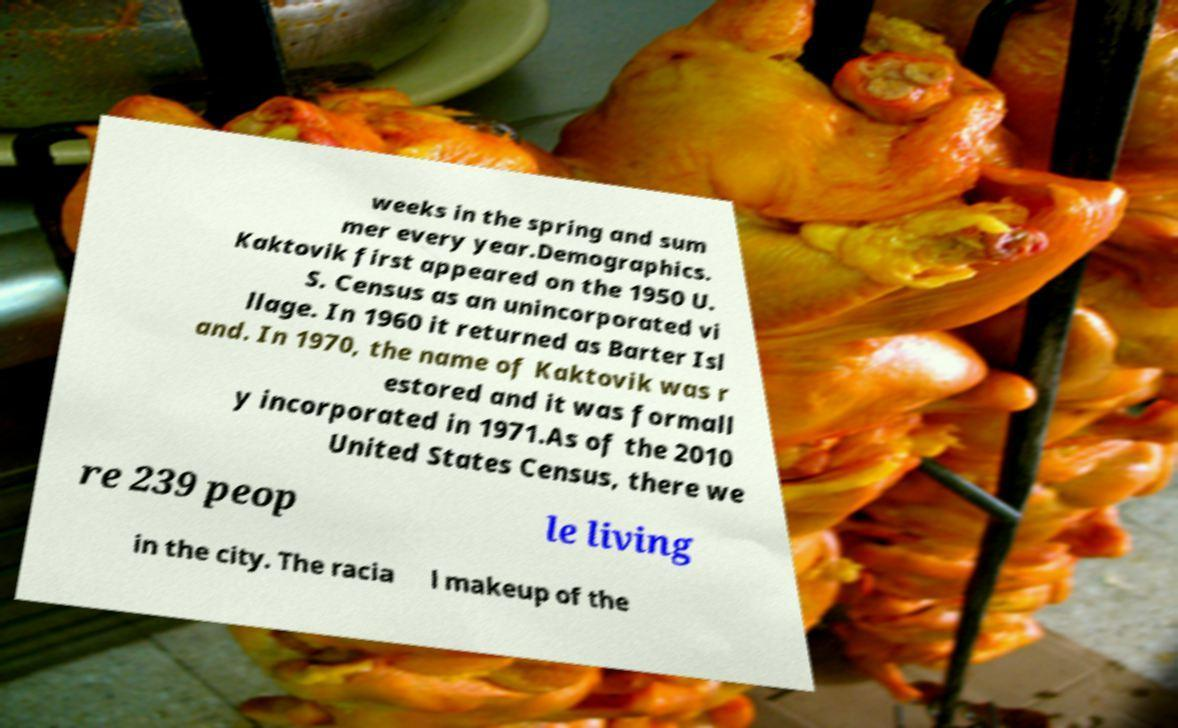Could you extract and type out the text from this image? weeks in the spring and sum mer every year.Demographics. Kaktovik first appeared on the 1950 U. S. Census as an unincorporated vi llage. In 1960 it returned as Barter Isl and. In 1970, the name of Kaktovik was r estored and it was formall y incorporated in 1971.As of the 2010 United States Census, there we re 239 peop le living in the city. The racia l makeup of the 